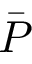Convert formula to latex. <formula><loc_0><loc_0><loc_500><loc_500>\bar { P }</formula> 